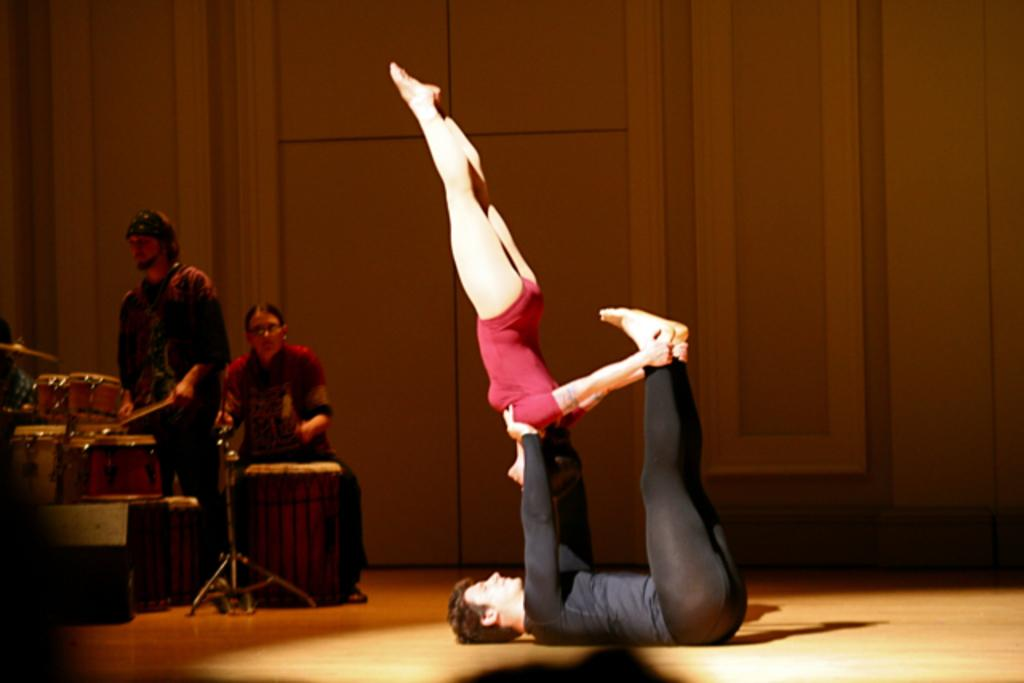How many people are in the image? There are four people in the image. What are the four people doing in the image? The four people form a musical band. What type of can is visible in the image? There is no can present in the image. Where is the chair located in the image? There is no chair present in the image. 